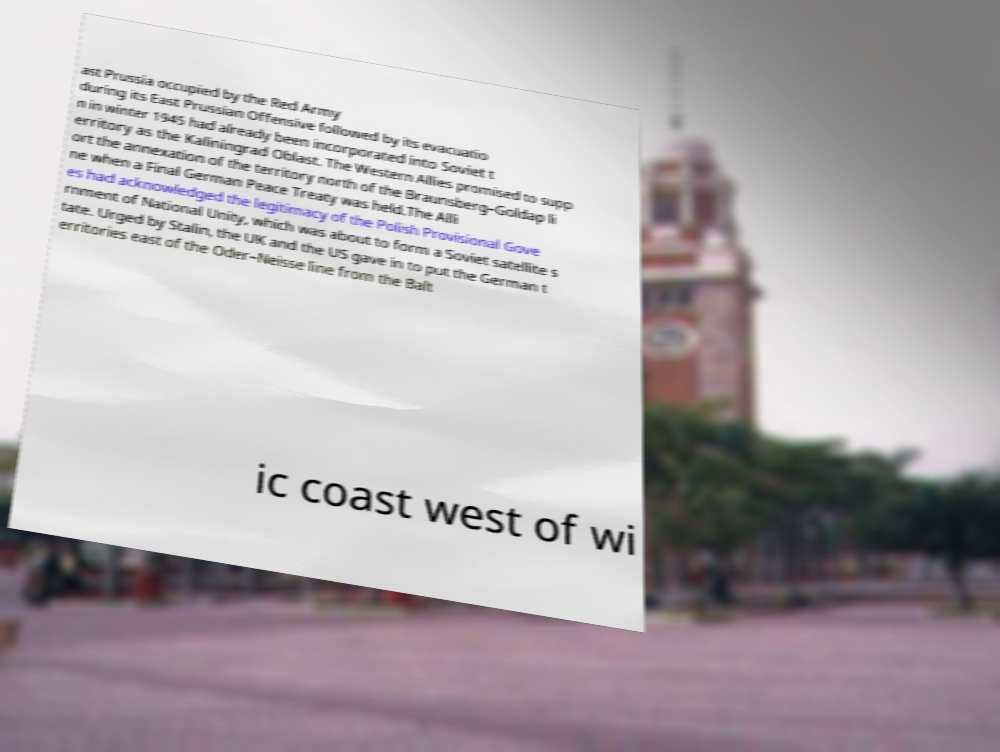I need the written content from this picture converted into text. Can you do that? ast Prussia occupied by the Red Army during its East Prussian Offensive followed by its evacuatio n in winter 1945 had already been incorporated into Soviet t erritory as the Kaliningrad Oblast. The Western Allies promised to supp ort the annexation of the territory north of the Braunsberg–Goldap li ne when a Final German Peace Treaty was held.The Alli es had acknowledged the legitimacy of the Polish Provisional Gove rnment of National Unity, which was about to form a Soviet satellite s tate. Urged by Stalin, the UK and the US gave in to put the German t erritories east of the Oder–Neisse line from the Balt ic coast west of wi 